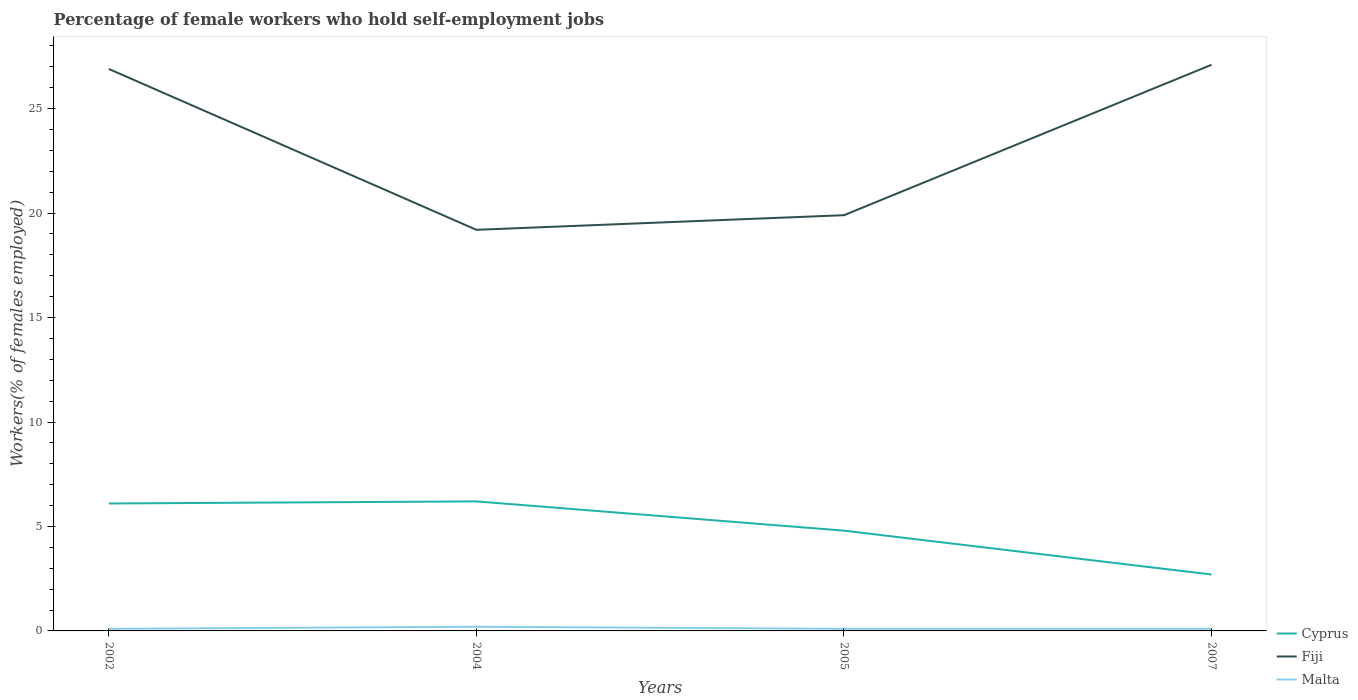Does the line corresponding to Cyprus intersect with the line corresponding to Malta?
Your answer should be very brief. No. Is the number of lines equal to the number of legend labels?
Your answer should be very brief. Yes. Across all years, what is the maximum percentage of self-employed female workers in Fiji?
Offer a terse response. 19.2. What is the total percentage of self-employed female workers in Fiji in the graph?
Offer a very short reply. 7. What is the difference between the highest and the second highest percentage of self-employed female workers in Cyprus?
Ensure brevity in your answer.  3.5. What is the difference between the highest and the lowest percentage of self-employed female workers in Malta?
Provide a succinct answer. 1. How many lines are there?
Make the answer very short. 3. Are the values on the major ticks of Y-axis written in scientific E-notation?
Keep it short and to the point. No. Where does the legend appear in the graph?
Ensure brevity in your answer.  Bottom right. What is the title of the graph?
Your response must be concise. Percentage of female workers who hold self-employment jobs. Does "Moldova" appear as one of the legend labels in the graph?
Offer a very short reply. No. What is the label or title of the Y-axis?
Give a very brief answer. Workers(% of females employed). What is the Workers(% of females employed) in Cyprus in 2002?
Ensure brevity in your answer.  6.1. What is the Workers(% of females employed) of Fiji in 2002?
Your response must be concise. 26.9. What is the Workers(% of females employed) in Malta in 2002?
Give a very brief answer. 0.1. What is the Workers(% of females employed) in Cyprus in 2004?
Ensure brevity in your answer.  6.2. What is the Workers(% of females employed) of Fiji in 2004?
Keep it short and to the point. 19.2. What is the Workers(% of females employed) in Malta in 2004?
Make the answer very short. 0.2. What is the Workers(% of females employed) in Cyprus in 2005?
Give a very brief answer. 4.8. What is the Workers(% of females employed) of Fiji in 2005?
Your answer should be very brief. 19.9. What is the Workers(% of females employed) of Malta in 2005?
Your answer should be compact. 0.1. What is the Workers(% of females employed) in Cyprus in 2007?
Provide a succinct answer. 2.7. What is the Workers(% of females employed) of Fiji in 2007?
Keep it short and to the point. 27.1. What is the Workers(% of females employed) of Malta in 2007?
Your answer should be very brief. 0.1. Across all years, what is the maximum Workers(% of females employed) of Cyprus?
Provide a succinct answer. 6.2. Across all years, what is the maximum Workers(% of females employed) in Fiji?
Ensure brevity in your answer.  27.1. Across all years, what is the maximum Workers(% of females employed) in Malta?
Your answer should be compact. 0.2. Across all years, what is the minimum Workers(% of females employed) in Cyprus?
Give a very brief answer. 2.7. Across all years, what is the minimum Workers(% of females employed) in Fiji?
Offer a very short reply. 19.2. Across all years, what is the minimum Workers(% of females employed) in Malta?
Offer a terse response. 0.1. What is the total Workers(% of females employed) in Cyprus in the graph?
Your answer should be very brief. 19.8. What is the total Workers(% of females employed) in Fiji in the graph?
Offer a terse response. 93.1. What is the difference between the Workers(% of females employed) in Fiji in 2002 and that in 2004?
Ensure brevity in your answer.  7.7. What is the difference between the Workers(% of females employed) of Malta in 2002 and that in 2005?
Keep it short and to the point. 0. What is the difference between the Workers(% of females employed) in Cyprus in 2002 and that in 2007?
Offer a terse response. 3.4. What is the difference between the Workers(% of females employed) in Fiji in 2004 and that in 2005?
Your answer should be compact. -0.7. What is the difference between the Workers(% of females employed) of Malta in 2004 and that in 2005?
Offer a terse response. 0.1. What is the difference between the Workers(% of females employed) of Cyprus in 2004 and that in 2007?
Your answer should be compact. 3.5. What is the difference between the Workers(% of females employed) in Fiji in 2004 and that in 2007?
Offer a very short reply. -7.9. What is the difference between the Workers(% of females employed) of Malta in 2004 and that in 2007?
Your response must be concise. 0.1. What is the difference between the Workers(% of females employed) of Cyprus in 2005 and that in 2007?
Make the answer very short. 2.1. What is the difference between the Workers(% of females employed) of Fiji in 2005 and that in 2007?
Offer a very short reply. -7.2. What is the difference between the Workers(% of females employed) of Malta in 2005 and that in 2007?
Give a very brief answer. 0. What is the difference between the Workers(% of females employed) in Cyprus in 2002 and the Workers(% of females employed) in Fiji in 2004?
Your response must be concise. -13.1. What is the difference between the Workers(% of females employed) in Cyprus in 2002 and the Workers(% of females employed) in Malta in 2004?
Your answer should be very brief. 5.9. What is the difference between the Workers(% of females employed) in Fiji in 2002 and the Workers(% of females employed) in Malta in 2004?
Your answer should be very brief. 26.7. What is the difference between the Workers(% of females employed) of Cyprus in 2002 and the Workers(% of females employed) of Fiji in 2005?
Your answer should be very brief. -13.8. What is the difference between the Workers(% of females employed) of Fiji in 2002 and the Workers(% of females employed) of Malta in 2005?
Your response must be concise. 26.8. What is the difference between the Workers(% of females employed) in Cyprus in 2002 and the Workers(% of females employed) in Malta in 2007?
Offer a very short reply. 6. What is the difference between the Workers(% of females employed) of Fiji in 2002 and the Workers(% of females employed) of Malta in 2007?
Keep it short and to the point. 26.8. What is the difference between the Workers(% of females employed) in Cyprus in 2004 and the Workers(% of females employed) in Fiji in 2005?
Provide a short and direct response. -13.7. What is the difference between the Workers(% of females employed) in Cyprus in 2004 and the Workers(% of females employed) in Malta in 2005?
Ensure brevity in your answer.  6.1. What is the difference between the Workers(% of females employed) of Cyprus in 2004 and the Workers(% of females employed) of Fiji in 2007?
Make the answer very short. -20.9. What is the difference between the Workers(% of females employed) of Cyprus in 2004 and the Workers(% of females employed) of Malta in 2007?
Your response must be concise. 6.1. What is the difference between the Workers(% of females employed) in Fiji in 2004 and the Workers(% of females employed) in Malta in 2007?
Give a very brief answer. 19.1. What is the difference between the Workers(% of females employed) of Cyprus in 2005 and the Workers(% of females employed) of Fiji in 2007?
Keep it short and to the point. -22.3. What is the difference between the Workers(% of females employed) of Fiji in 2005 and the Workers(% of females employed) of Malta in 2007?
Keep it short and to the point. 19.8. What is the average Workers(% of females employed) of Cyprus per year?
Offer a very short reply. 4.95. What is the average Workers(% of females employed) of Fiji per year?
Your answer should be compact. 23.27. What is the average Workers(% of females employed) in Malta per year?
Offer a very short reply. 0.12. In the year 2002, what is the difference between the Workers(% of females employed) in Cyprus and Workers(% of females employed) in Fiji?
Give a very brief answer. -20.8. In the year 2002, what is the difference between the Workers(% of females employed) in Fiji and Workers(% of females employed) in Malta?
Your response must be concise. 26.8. In the year 2004, what is the difference between the Workers(% of females employed) of Fiji and Workers(% of females employed) of Malta?
Ensure brevity in your answer.  19. In the year 2005, what is the difference between the Workers(% of females employed) of Cyprus and Workers(% of females employed) of Fiji?
Your answer should be very brief. -15.1. In the year 2005, what is the difference between the Workers(% of females employed) of Fiji and Workers(% of females employed) of Malta?
Ensure brevity in your answer.  19.8. In the year 2007, what is the difference between the Workers(% of females employed) in Cyprus and Workers(% of females employed) in Fiji?
Offer a terse response. -24.4. In the year 2007, what is the difference between the Workers(% of females employed) in Cyprus and Workers(% of females employed) in Malta?
Your answer should be very brief. 2.6. What is the ratio of the Workers(% of females employed) of Cyprus in 2002 to that in 2004?
Ensure brevity in your answer.  0.98. What is the ratio of the Workers(% of females employed) in Fiji in 2002 to that in 2004?
Give a very brief answer. 1.4. What is the ratio of the Workers(% of females employed) in Cyprus in 2002 to that in 2005?
Ensure brevity in your answer.  1.27. What is the ratio of the Workers(% of females employed) of Fiji in 2002 to that in 2005?
Ensure brevity in your answer.  1.35. What is the ratio of the Workers(% of females employed) of Cyprus in 2002 to that in 2007?
Give a very brief answer. 2.26. What is the ratio of the Workers(% of females employed) in Malta in 2002 to that in 2007?
Provide a succinct answer. 1. What is the ratio of the Workers(% of females employed) in Cyprus in 2004 to that in 2005?
Give a very brief answer. 1.29. What is the ratio of the Workers(% of females employed) of Fiji in 2004 to that in 2005?
Offer a very short reply. 0.96. What is the ratio of the Workers(% of females employed) in Cyprus in 2004 to that in 2007?
Your answer should be very brief. 2.3. What is the ratio of the Workers(% of females employed) in Fiji in 2004 to that in 2007?
Give a very brief answer. 0.71. What is the ratio of the Workers(% of females employed) in Malta in 2004 to that in 2007?
Your answer should be very brief. 2. What is the ratio of the Workers(% of females employed) of Cyprus in 2005 to that in 2007?
Provide a succinct answer. 1.78. What is the ratio of the Workers(% of females employed) of Fiji in 2005 to that in 2007?
Offer a very short reply. 0.73. What is the ratio of the Workers(% of females employed) in Malta in 2005 to that in 2007?
Your response must be concise. 1. What is the difference between the highest and the second highest Workers(% of females employed) of Cyprus?
Provide a short and direct response. 0.1. What is the difference between the highest and the second highest Workers(% of females employed) of Fiji?
Give a very brief answer. 0.2. 